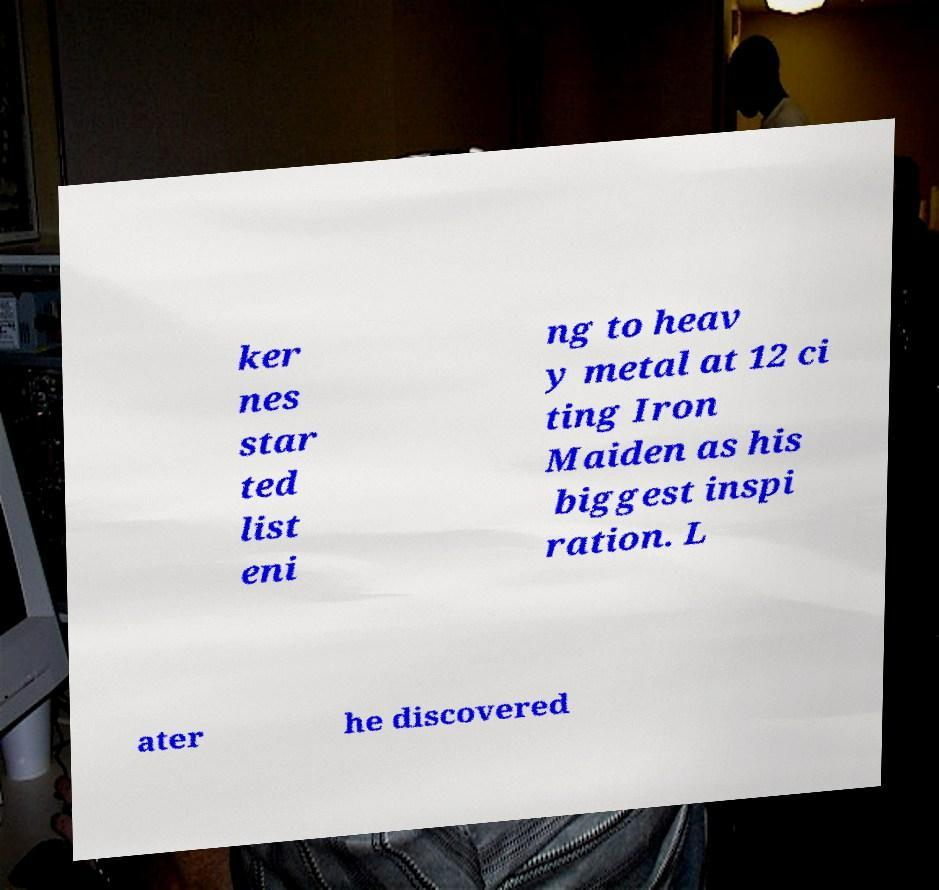Can you accurately transcribe the text from the provided image for me? ker nes star ted list eni ng to heav y metal at 12 ci ting Iron Maiden as his biggest inspi ration. L ater he discovered 